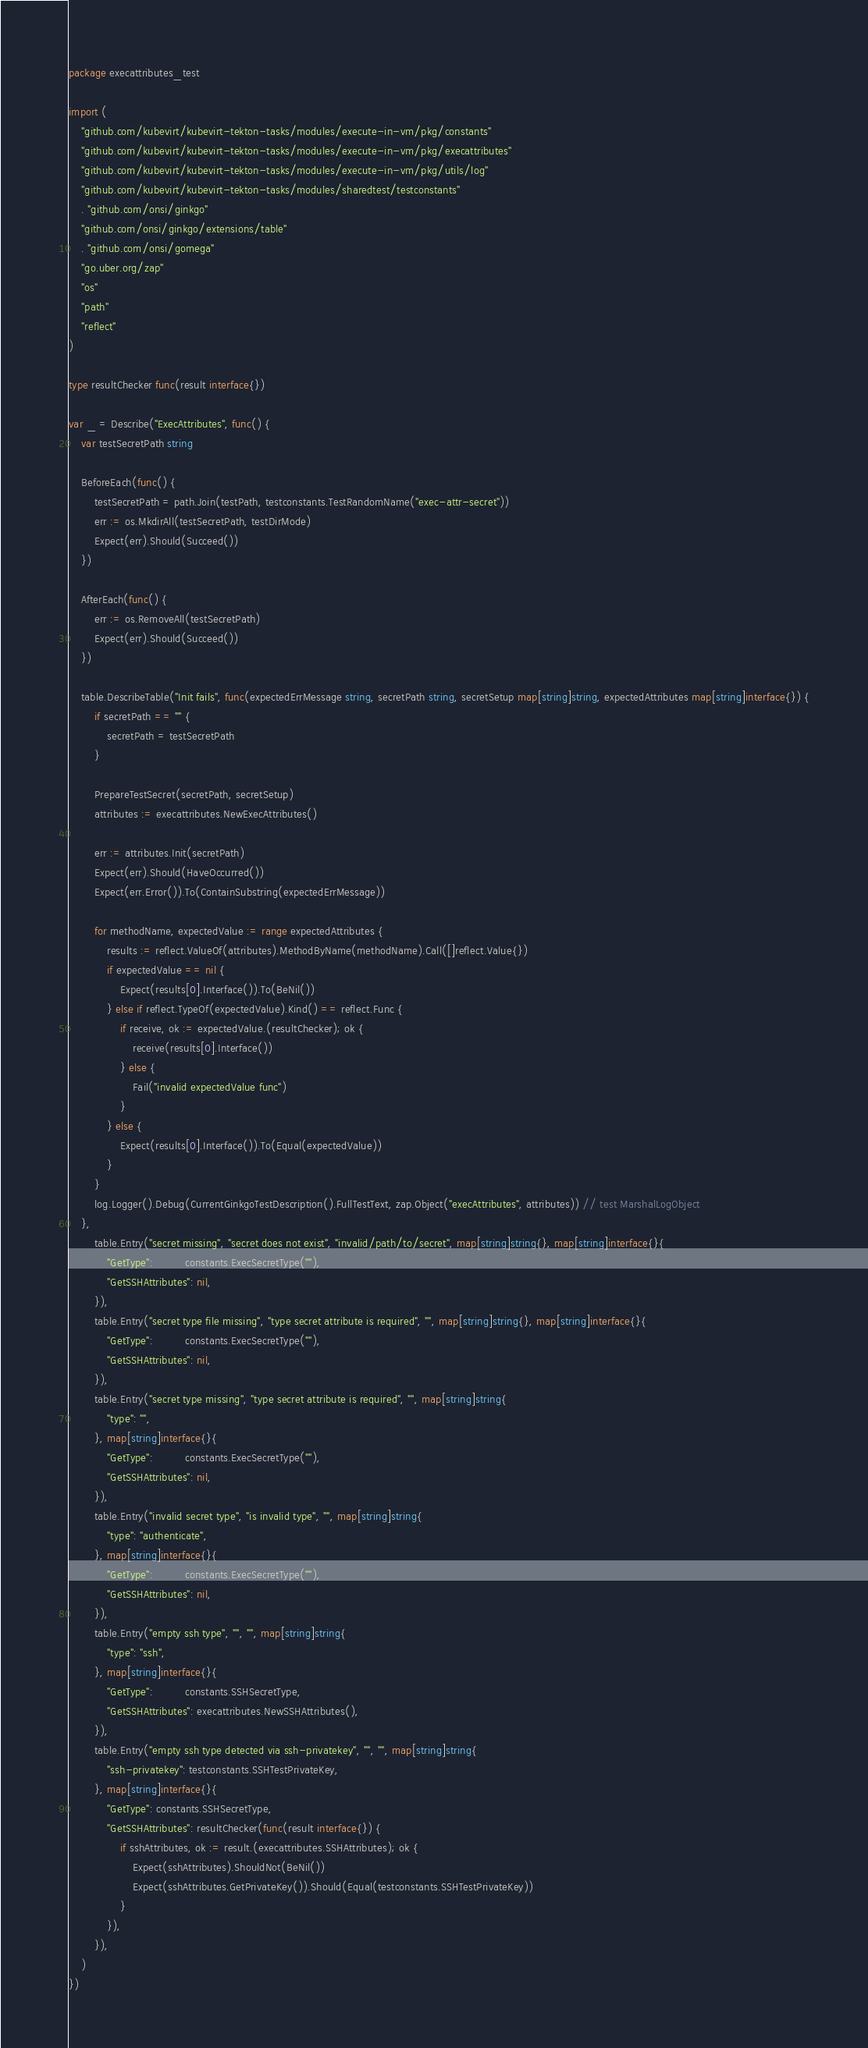<code> <loc_0><loc_0><loc_500><loc_500><_Go_>package execattributes_test

import (
	"github.com/kubevirt/kubevirt-tekton-tasks/modules/execute-in-vm/pkg/constants"
	"github.com/kubevirt/kubevirt-tekton-tasks/modules/execute-in-vm/pkg/execattributes"
	"github.com/kubevirt/kubevirt-tekton-tasks/modules/execute-in-vm/pkg/utils/log"
	"github.com/kubevirt/kubevirt-tekton-tasks/modules/sharedtest/testconstants"
	. "github.com/onsi/ginkgo"
	"github.com/onsi/ginkgo/extensions/table"
	. "github.com/onsi/gomega"
	"go.uber.org/zap"
	"os"
	"path"
	"reflect"
)

type resultChecker func(result interface{})

var _ = Describe("ExecAttributes", func() {
	var testSecretPath string

	BeforeEach(func() {
		testSecretPath = path.Join(testPath, testconstants.TestRandomName("exec-attr-secret"))
		err := os.MkdirAll(testSecretPath, testDirMode)
		Expect(err).Should(Succeed())
	})

	AfterEach(func() {
		err := os.RemoveAll(testSecretPath)
		Expect(err).Should(Succeed())
	})

	table.DescribeTable("Init fails", func(expectedErrMessage string, secretPath string, secretSetup map[string]string, expectedAttributes map[string]interface{}) {
		if secretPath == "" {
			secretPath = testSecretPath
		}

		PrepareTestSecret(secretPath, secretSetup)
		attributes := execattributes.NewExecAttributes()

		err := attributes.Init(secretPath)
		Expect(err).Should(HaveOccurred())
		Expect(err.Error()).To(ContainSubstring(expectedErrMessage))

		for methodName, expectedValue := range expectedAttributes {
			results := reflect.ValueOf(attributes).MethodByName(methodName).Call([]reflect.Value{})
			if expectedValue == nil {
				Expect(results[0].Interface()).To(BeNil())
			} else if reflect.TypeOf(expectedValue).Kind() == reflect.Func {
				if receive, ok := expectedValue.(resultChecker); ok {
					receive(results[0].Interface())
				} else {
					Fail("invalid expectedValue func")
				}
			} else {
				Expect(results[0].Interface()).To(Equal(expectedValue))
			}
		}
		log.Logger().Debug(CurrentGinkgoTestDescription().FullTestText, zap.Object("execAttributes", attributes)) // test MarshalLogObject
	},
		table.Entry("secret missing", "secret does not exist", "invalid/path/to/secret", map[string]string{}, map[string]interface{}{
			"GetType":          constants.ExecSecretType(""),
			"GetSSHAttributes": nil,
		}),
		table.Entry("secret type file missing", "type secret attribute is required", "", map[string]string{}, map[string]interface{}{
			"GetType":          constants.ExecSecretType(""),
			"GetSSHAttributes": nil,
		}),
		table.Entry("secret type missing", "type secret attribute is required", "", map[string]string{
			"type": "",
		}, map[string]interface{}{
			"GetType":          constants.ExecSecretType(""),
			"GetSSHAttributes": nil,
		}),
		table.Entry("invalid secret type", "is invalid type", "", map[string]string{
			"type": "authenticate",
		}, map[string]interface{}{
			"GetType":          constants.ExecSecretType(""),
			"GetSSHAttributes": nil,
		}),
		table.Entry("empty ssh type", "", "", map[string]string{
			"type": "ssh",
		}, map[string]interface{}{
			"GetType":          constants.SSHSecretType,
			"GetSSHAttributes": execattributes.NewSSHAttributes(),
		}),
		table.Entry("empty ssh type detected via ssh-privatekey", "", "", map[string]string{
			"ssh-privatekey": testconstants.SSHTestPrivateKey,
		}, map[string]interface{}{
			"GetType": constants.SSHSecretType,
			"GetSSHAttributes": resultChecker(func(result interface{}) {
				if sshAttributes, ok := result.(execattributes.SSHAttributes); ok {
					Expect(sshAttributes).ShouldNot(BeNil())
					Expect(sshAttributes.GetPrivateKey()).Should(Equal(testconstants.SSHTestPrivateKey))
				}
			}),
		}),
	)
})
</code> 